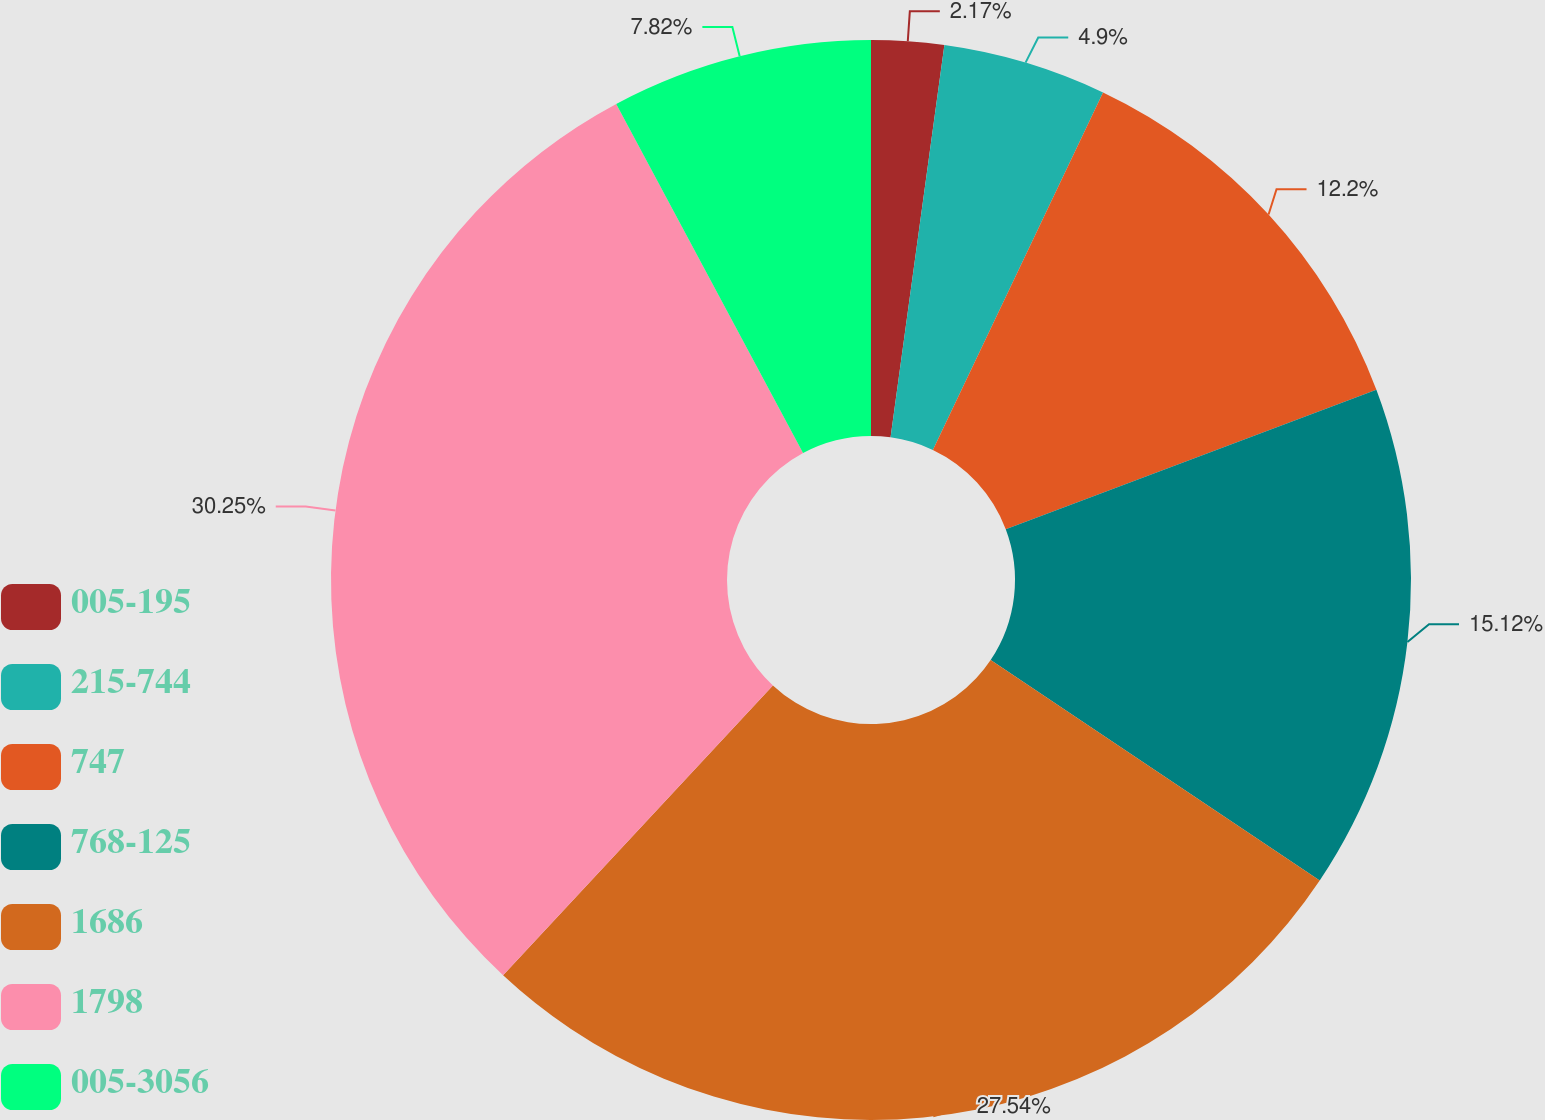Convert chart. <chart><loc_0><loc_0><loc_500><loc_500><pie_chart><fcel>005-195<fcel>215-744<fcel>747<fcel>768-125<fcel>1686<fcel>1798<fcel>005-3056<nl><fcel>2.17%<fcel>4.9%<fcel>12.2%<fcel>15.12%<fcel>27.54%<fcel>30.25%<fcel>7.82%<nl></chart> 